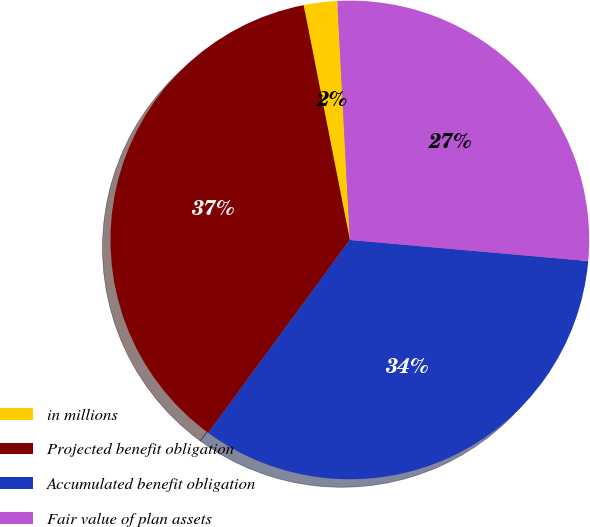Convert chart. <chart><loc_0><loc_0><loc_500><loc_500><pie_chart><fcel>in millions<fcel>Projected benefit obligation<fcel>Accumulated benefit obligation<fcel>Fair value of plan assets<nl><fcel>2.26%<fcel>36.84%<fcel>33.67%<fcel>27.24%<nl></chart> 